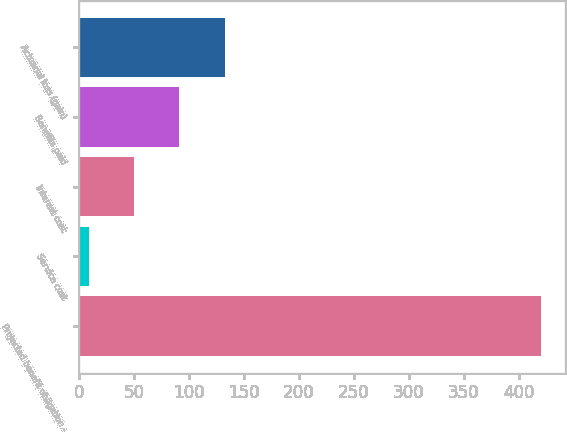<chart> <loc_0><loc_0><loc_500><loc_500><bar_chart><fcel>Projected benefit obligation -<fcel>Service cost<fcel>Interest cost<fcel>Benefits paid<fcel>Actuarial loss (gain)<nl><fcel>420.7<fcel>8.7<fcel>49.9<fcel>91.1<fcel>132.3<nl></chart> 